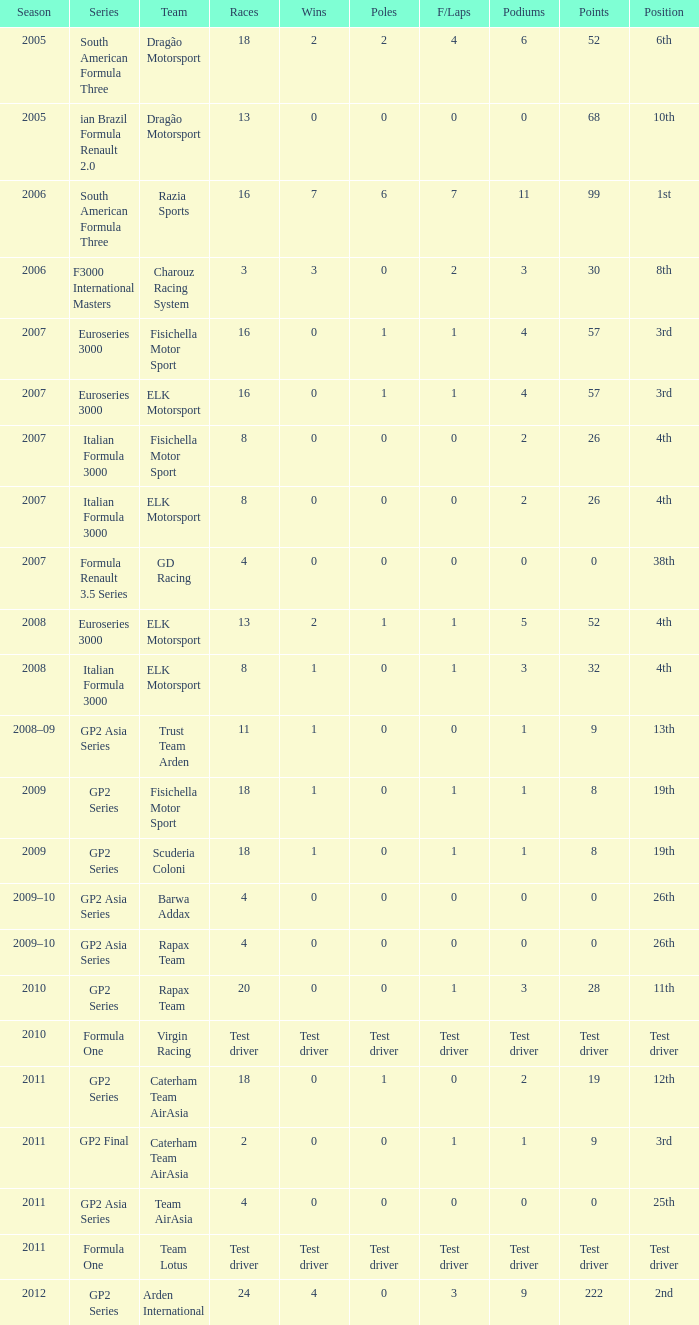What were the points in the year when his Wins were 0, his Podiums were 0, and he drove in 4 races? 0, 0, 0, 0. Write the full table. {'header': ['Season', 'Series', 'Team', 'Races', 'Wins', 'Poles', 'F/Laps', 'Podiums', 'Points', 'Position'], 'rows': [['2005', 'South American Formula Three', 'Dragão Motorsport', '18', '2', '2', '4', '6', '52', '6th'], ['2005', 'ian Brazil Formula Renault 2.0', 'Dragão Motorsport', '13', '0', '0', '0', '0', '68', '10th'], ['2006', 'South American Formula Three', 'Razia Sports', '16', '7', '6', '7', '11', '99', '1st'], ['2006', 'F3000 International Masters', 'Charouz Racing System', '3', '3', '0', '2', '3', '30', '8th'], ['2007', 'Euroseries 3000', 'Fisichella Motor Sport', '16', '0', '1', '1', '4', '57', '3rd'], ['2007', 'Euroseries 3000', 'ELK Motorsport', '16', '0', '1', '1', '4', '57', '3rd'], ['2007', 'Italian Formula 3000', 'Fisichella Motor Sport', '8', '0', '0', '0', '2', '26', '4th'], ['2007', 'Italian Formula 3000', 'ELK Motorsport', '8', '0', '0', '0', '2', '26', '4th'], ['2007', 'Formula Renault 3.5 Series', 'GD Racing', '4', '0', '0', '0', '0', '0', '38th'], ['2008', 'Euroseries 3000', 'ELK Motorsport', '13', '2', '1', '1', '5', '52', '4th'], ['2008', 'Italian Formula 3000', 'ELK Motorsport', '8', '1', '0', '1', '3', '32', '4th'], ['2008–09', 'GP2 Asia Series', 'Trust Team Arden', '11', '1', '0', '0', '1', '9', '13th'], ['2009', 'GP2 Series', 'Fisichella Motor Sport', '18', '1', '0', '1', '1', '8', '19th'], ['2009', 'GP2 Series', 'Scuderia Coloni', '18', '1', '0', '1', '1', '8', '19th'], ['2009–10', 'GP2 Asia Series', 'Barwa Addax', '4', '0', '0', '0', '0', '0', '26th'], ['2009–10', 'GP2 Asia Series', 'Rapax Team', '4', '0', '0', '0', '0', '0', '26th'], ['2010', 'GP2 Series', 'Rapax Team', '20', '0', '0', '1', '3', '28', '11th'], ['2010', 'Formula One', 'Virgin Racing', 'Test driver', 'Test driver', 'Test driver', 'Test driver', 'Test driver', 'Test driver', 'Test driver'], ['2011', 'GP2 Series', 'Caterham Team AirAsia', '18', '0', '1', '0', '2', '19', '12th'], ['2011', 'GP2 Final', 'Caterham Team AirAsia', '2', '0', '0', '1', '1', '9', '3rd'], ['2011', 'GP2 Asia Series', 'Team AirAsia', '4', '0', '0', '0', '0', '0', '25th'], ['2011', 'Formula One', 'Team Lotus', 'Test driver', 'Test driver', 'Test driver', 'Test driver', 'Test driver', 'Test driver', 'Test driver'], ['2012', 'GP2 Series', 'Arden International', '24', '4', '0', '3', '9', '222', '2nd']]} 